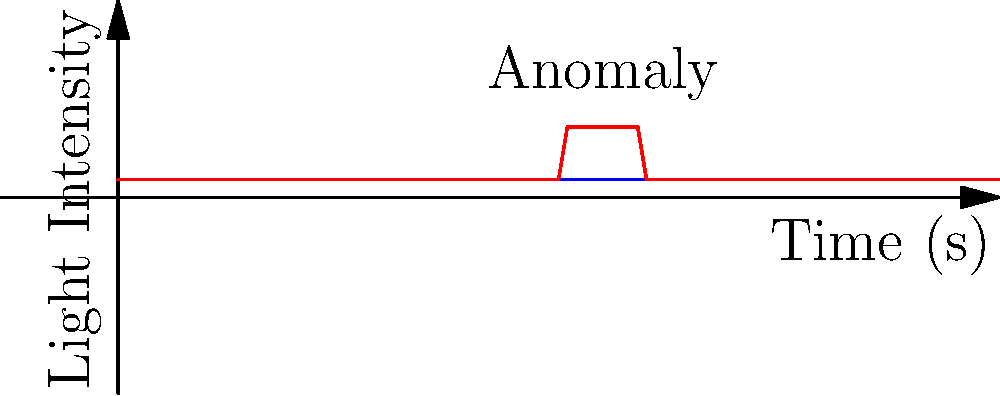In the night vision camera footage analysis shown above, what could the sudden spike in light intensity around the 5-second mark potentially indicate in the context of paranormal investigation? To interpret this night vision camera footage for potential paranormal activity, follow these steps:

1. Observe the baseline: The blue line represents the normal light intensity in the environment, which remains constant at about 0.2 on the scale.

2. Identify the anomaly: The red line shows a sudden spike in light intensity, reaching about 0.8 on the scale, between the 5 and 6-second marks.

3. Consider natural explanations: Before jumping to paranormal conclusions, rule out common causes such as:
   a) A passing car's headlights
   b) Someone turning on a light in the vicinity
   c) An animal or person moving through the frame

4. Analyze the spike characteristics:
   a) Duration: The spike is brief, lasting about 1 second
   b) Intensity: It's significantly higher than the baseline
   c) Shape: It has a sharp rise and fall

5. Compare to known paranormal phenomena: Some investigators associate sudden, brief light anomalies with potential spirit energy manifestations or orbs.

6. Cross-reference with other data: Check if this light anomaly coincides with other unusual readings (e.g., EMF spikes, temperature drops) or personal experiences.

7. Consider the location's history: If the site has a reputation for paranormal activity, this could support the possibility of a ghostly manifestation.

Given the sudden, brief nature of the light intensity spike and assuming other natural causes have been ruled out, this anomaly could potentially indicate a momentary paranormal energy manifestation or the presence of a spirit entity interacting with the environment.
Answer: Potential spirit energy manifestation or orb 